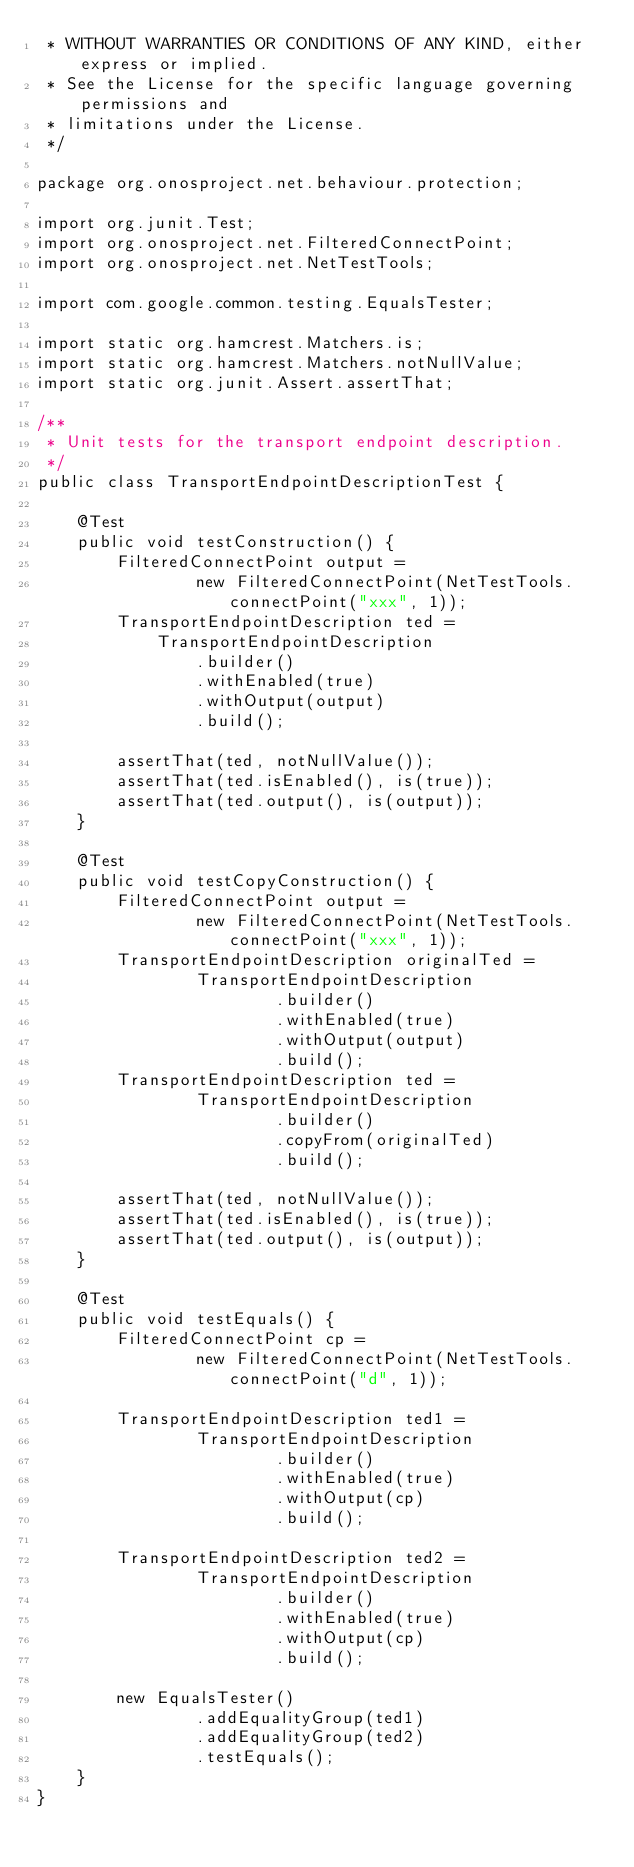<code> <loc_0><loc_0><loc_500><loc_500><_Java_> * WITHOUT WARRANTIES OR CONDITIONS OF ANY KIND, either express or implied.
 * See the License for the specific language governing permissions and
 * limitations under the License.
 */

package org.onosproject.net.behaviour.protection;

import org.junit.Test;
import org.onosproject.net.FilteredConnectPoint;
import org.onosproject.net.NetTestTools;

import com.google.common.testing.EqualsTester;

import static org.hamcrest.Matchers.is;
import static org.hamcrest.Matchers.notNullValue;
import static org.junit.Assert.assertThat;

/**
 * Unit tests for the transport endpoint description.
 */
public class TransportEndpointDescriptionTest {

    @Test
    public void testConstruction() {
        FilteredConnectPoint output =
                new FilteredConnectPoint(NetTestTools.connectPoint("xxx", 1));
        TransportEndpointDescription ted =
            TransportEndpointDescription
                .builder()
                .withEnabled(true)
                .withOutput(output)
                .build();

        assertThat(ted, notNullValue());
        assertThat(ted.isEnabled(), is(true));
        assertThat(ted.output(), is(output));
    }

    @Test
    public void testCopyConstruction() {
        FilteredConnectPoint output =
                new FilteredConnectPoint(NetTestTools.connectPoint("xxx", 1));
        TransportEndpointDescription originalTed =
                TransportEndpointDescription
                        .builder()
                        .withEnabled(true)
                        .withOutput(output)
                        .build();
        TransportEndpointDescription ted =
                TransportEndpointDescription
                        .builder()
                        .copyFrom(originalTed)
                        .build();

        assertThat(ted, notNullValue());
        assertThat(ted.isEnabled(), is(true));
        assertThat(ted.output(), is(output));
    }

    @Test
    public void testEquals() {
        FilteredConnectPoint cp =
                new FilteredConnectPoint(NetTestTools.connectPoint("d", 1));

        TransportEndpointDescription ted1 =
                TransportEndpointDescription
                        .builder()
                        .withEnabled(true)
                        .withOutput(cp)
                        .build();

        TransportEndpointDescription ted2 =
                TransportEndpointDescription
                        .builder()
                        .withEnabled(true)
                        .withOutput(cp)
                        .build();

        new EqualsTester()
                .addEqualityGroup(ted1)
                .addEqualityGroup(ted2)
                .testEquals();
    }
}
</code> 